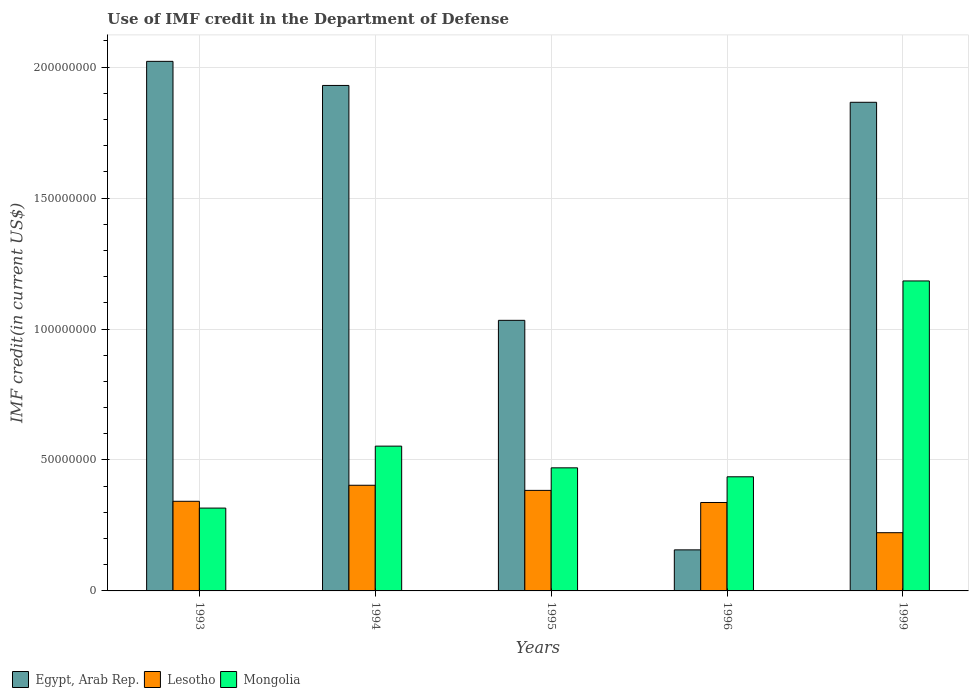How many different coloured bars are there?
Your answer should be very brief. 3. How many groups of bars are there?
Your answer should be very brief. 5. Are the number of bars per tick equal to the number of legend labels?
Your answer should be very brief. Yes. Are the number of bars on each tick of the X-axis equal?
Offer a very short reply. Yes. How many bars are there on the 1st tick from the left?
Ensure brevity in your answer.  3. In how many cases, is the number of bars for a given year not equal to the number of legend labels?
Your answer should be compact. 0. What is the IMF credit in the Department of Defense in Egypt, Arab Rep. in 1994?
Your response must be concise. 1.93e+08. Across all years, what is the maximum IMF credit in the Department of Defense in Mongolia?
Provide a succinct answer. 1.18e+08. Across all years, what is the minimum IMF credit in the Department of Defense in Mongolia?
Your answer should be very brief. 3.16e+07. In which year was the IMF credit in the Department of Defense in Lesotho maximum?
Your answer should be compact. 1994. What is the total IMF credit in the Department of Defense in Mongolia in the graph?
Offer a terse response. 2.96e+08. What is the difference between the IMF credit in the Department of Defense in Egypt, Arab Rep. in 1993 and that in 1994?
Provide a short and direct response. 9.20e+06. What is the difference between the IMF credit in the Department of Defense in Lesotho in 1993 and the IMF credit in the Department of Defense in Egypt, Arab Rep. in 1996?
Make the answer very short. 1.85e+07. What is the average IMF credit in the Department of Defense in Lesotho per year?
Provide a succinct answer. 3.38e+07. In the year 1996, what is the difference between the IMF credit in the Department of Defense in Lesotho and IMF credit in the Department of Defense in Mongolia?
Your answer should be compact. -9.81e+06. In how many years, is the IMF credit in the Department of Defense in Mongolia greater than 80000000 US$?
Keep it short and to the point. 1. What is the ratio of the IMF credit in the Department of Defense in Lesotho in 1995 to that in 1996?
Your answer should be compact. 1.14. Is the difference between the IMF credit in the Department of Defense in Lesotho in 1993 and 1994 greater than the difference between the IMF credit in the Department of Defense in Mongolia in 1993 and 1994?
Offer a terse response. Yes. What is the difference between the highest and the second highest IMF credit in the Department of Defense in Egypt, Arab Rep.?
Ensure brevity in your answer.  9.20e+06. What is the difference between the highest and the lowest IMF credit in the Department of Defense in Egypt, Arab Rep.?
Your answer should be very brief. 1.87e+08. Is the sum of the IMF credit in the Department of Defense in Lesotho in 1995 and 1999 greater than the maximum IMF credit in the Department of Defense in Mongolia across all years?
Your answer should be very brief. No. What does the 1st bar from the left in 1995 represents?
Your answer should be very brief. Egypt, Arab Rep. What does the 1st bar from the right in 1996 represents?
Your answer should be compact. Mongolia. How many bars are there?
Make the answer very short. 15. Does the graph contain grids?
Offer a very short reply. Yes. Where does the legend appear in the graph?
Ensure brevity in your answer.  Bottom left. How many legend labels are there?
Offer a terse response. 3. What is the title of the graph?
Keep it short and to the point. Use of IMF credit in the Department of Defense. Does "Vanuatu" appear as one of the legend labels in the graph?
Ensure brevity in your answer.  No. What is the label or title of the X-axis?
Offer a terse response. Years. What is the label or title of the Y-axis?
Your answer should be very brief. IMF credit(in current US$). What is the IMF credit(in current US$) in Egypt, Arab Rep. in 1993?
Offer a very short reply. 2.02e+08. What is the IMF credit(in current US$) in Lesotho in 1993?
Make the answer very short. 3.42e+07. What is the IMF credit(in current US$) of Mongolia in 1993?
Keep it short and to the point. 3.16e+07. What is the IMF credit(in current US$) in Egypt, Arab Rep. in 1994?
Offer a terse response. 1.93e+08. What is the IMF credit(in current US$) of Lesotho in 1994?
Provide a succinct answer. 4.03e+07. What is the IMF credit(in current US$) in Mongolia in 1994?
Give a very brief answer. 5.53e+07. What is the IMF credit(in current US$) of Egypt, Arab Rep. in 1995?
Offer a terse response. 1.03e+08. What is the IMF credit(in current US$) in Lesotho in 1995?
Provide a short and direct response. 3.84e+07. What is the IMF credit(in current US$) in Mongolia in 1995?
Offer a very short reply. 4.70e+07. What is the IMF credit(in current US$) in Egypt, Arab Rep. in 1996?
Provide a short and direct response. 1.57e+07. What is the IMF credit(in current US$) of Lesotho in 1996?
Your response must be concise. 3.38e+07. What is the IMF credit(in current US$) of Mongolia in 1996?
Give a very brief answer. 4.36e+07. What is the IMF credit(in current US$) in Egypt, Arab Rep. in 1999?
Your answer should be very brief. 1.87e+08. What is the IMF credit(in current US$) in Lesotho in 1999?
Ensure brevity in your answer.  2.22e+07. What is the IMF credit(in current US$) of Mongolia in 1999?
Keep it short and to the point. 1.18e+08. Across all years, what is the maximum IMF credit(in current US$) of Egypt, Arab Rep.?
Your response must be concise. 2.02e+08. Across all years, what is the maximum IMF credit(in current US$) of Lesotho?
Provide a succinct answer. 4.03e+07. Across all years, what is the maximum IMF credit(in current US$) in Mongolia?
Your answer should be compact. 1.18e+08. Across all years, what is the minimum IMF credit(in current US$) of Egypt, Arab Rep.?
Offer a very short reply. 1.57e+07. Across all years, what is the minimum IMF credit(in current US$) in Lesotho?
Your answer should be very brief. 2.22e+07. Across all years, what is the minimum IMF credit(in current US$) of Mongolia?
Offer a terse response. 3.16e+07. What is the total IMF credit(in current US$) of Egypt, Arab Rep. in the graph?
Ensure brevity in your answer.  7.01e+08. What is the total IMF credit(in current US$) in Lesotho in the graph?
Offer a very short reply. 1.69e+08. What is the total IMF credit(in current US$) in Mongolia in the graph?
Your answer should be very brief. 2.96e+08. What is the difference between the IMF credit(in current US$) of Egypt, Arab Rep. in 1993 and that in 1994?
Keep it short and to the point. 9.20e+06. What is the difference between the IMF credit(in current US$) of Lesotho in 1993 and that in 1994?
Provide a short and direct response. -6.12e+06. What is the difference between the IMF credit(in current US$) of Mongolia in 1993 and that in 1994?
Your answer should be very brief. -2.37e+07. What is the difference between the IMF credit(in current US$) of Egypt, Arab Rep. in 1993 and that in 1995?
Ensure brevity in your answer.  9.89e+07. What is the difference between the IMF credit(in current US$) in Lesotho in 1993 and that in 1995?
Offer a very short reply. -4.16e+06. What is the difference between the IMF credit(in current US$) in Mongolia in 1993 and that in 1995?
Keep it short and to the point. -1.54e+07. What is the difference between the IMF credit(in current US$) in Egypt, Arab Rep. in 1993 and that in 1996?
Provide a short and direct response. 1.87e+08. What is the difference between the IMF credit(in current US$) in Lesotho in 1993 and that in 1996?
Provide a succinct answer. 4.57e+05. What is the difference between the IMF credit(in current US$) of Mongolia in 1993 and that in 1996?
Offer a terse response. -1.20e+07. What is the difference between the IMF credit(in current US$) of Egypt, Arab Rep. in 1993 and that in 1999?
Keep it short and to the point. 1.56e+07. What is the difference between the IMF credit(in current US$) in Lesotho in 1993 and that in 1999?
Your answer should be compact. 1.20e+07. What is the difference between the IMF credit(in current US$) of Mongolia in 1993 and that in 1999?
Offer a terse response. -8.67e+07. What is the difference between the IMF credit(in current US$) of Egypt, Arab Rep. in 1994 and that in 1995?
Your answer should be compact. 8.97e+07. What is the difference between the IMF credit(in current US$) in Lesotho in 1994 and that in 1995?
Your response must be concise. 1.96e+06. What is the difference between the IMF credit(in current US$) of Mongolia in 1994 and that in 1995?
Provide a succinct answer. 8.28e+06. What is the difference between the IMF credit(in current US$) in Egypt, Arab Rep. in 1994 and that in 1996?
Provide a succinct answer. 1.77e+08. What is the difference between the IMF credit(in current US$) of Lesotho in 1994 and that in 1996?
Give a very brief answer. 6.58e+06. What is the difference between the IMF credit(in current US$) of Mongolia in 1994 and that in 1996?
Provide a succinct answer. 1.17e+07. What is the difference between the IMF credit(in current US$) in Egypt, Arab Rep. in 1994 and that in 1999?
Offer a very short reply. 6.44e+06. What is the difference between the IMF credit(in current US$) of Lesotho in 1994 and that in 1999?
Offer a terse response. 1.81e+07. What is the difference between the IMF credit(in current US$) in Mongolia in 1994 and that in 1999?
Your answer should be compact. -6.31e+07. What is the difference between the IMF credit(in current US$) in Egypt, Arab Rep. in 1995 and that in 1996?
Make the answer very short. 8.76e+07. What is the difference between the IMF credit(in current US$) in Lesotho in 1995 and that in 1996?
Offer a terse response. 4.62e+06. What is the difference between the IMF credit(in current US$) of Mongolia in 1995 and that in 1996?
Your answer should be very brief. 3.42e+06. What is the difference between the IMF credit(in current US$) in Egypt, Arab Rep. in 1995 and that in 1999?
Provide a short and direct response. -8.32e+07. What is the difference between the IMF credit(in current US$) of Lesotho in 1995 and that in 1999?
Provide a succinct answer. 1.62e+07. What is the difference between the IMF credit(in current US$) of Mongolia in 1995 and that in 1999?
Your answer should be very brief. -7.14e+07. What is the difference between the IMF credit(in current US$) in Egypt, Arab Rep. in 1996 and that in 1999?
Keep it short and to the point. -1.71e+08. What is the difference between the IMF credit(in current US$) of Lesotho in 1996 and that in 1999?
Provide a succinct answer. 1.15e+07. What is the difference between the IMF credit(in current US$) of Mongolia in 1996 and that in 1999?
Make the answer very short. -7.48e+07. What is the difference between the IMF credit(in current US$) of Egypt, Arab Rep. in 1993 and the IMF credit(in current US$) of Lesotho in 1994?
Your answer should be very brief. 1.62e+08. What is the difference between the IMF credit(in current US$) in Egypt, Arab Rep. in 1993 and the IMF credit(in current US$) in Mongolia in 1994?
Your answer should be compact. 1.47e+08. What is the difference between the IMF credit(in current US$) in Lesotho in 1993 and the IMF credit(in current US$) in Mongolia in 1994?
Offer a very short reply. -2.11e+07. What is the difference between the IMF credit(in current US$) of Egypt, Arab Rep. in 1993 and the IMF credit(in current US$) of Lesotho in 1995?
Offer a very short reply. 1.64e+08. What is the difference between the IMF credit(in current US$) in Egypt, Arab Rep. in 1993 and the IMF credit(in current US$) in Mongolia in 1995?
Make the answer very short. 1.55e+08. What is the difference between the IMF credit(in current US$) in Lesotho in 1993 and the IMF credit(in current US$) in Mongolia in 1995?
Offer a terse response. -1.28e+07. What is the difference between the IMF credit(in current US$) in Egypt, Arab Rep. in 1993 and the IMF credit(in current US$) in Lesotho in 1996?
Provide a short and direct response. 1.68e+08. What is the difference between the IMF credit(in current US$) in Egypt, Arab Rep. in 1993 and the IMF credit(in current US$) in Mongolia in 1996?
Provide a succinct answer. 1.59e+08. What is the difference between the IMF credit(in current US$) in Lesotho in 1993 and the IMF credit(in current US$) in Mongolia in 1996?
Your answer should be very brief. -9.36e+06. What is the difference between the IMF credit(in current US$) in Egypt, Arab Rep. in 1993 and the IMF credit(in current US$) in Lesotho in 1999?
Give a very brief answer. 1.80e+08. What is the difference between the IMF credit(in current US$) of Egypt, Arab Rep. in 1993 and the IMF credit(in current US$) of Mongolia in 1999?
Keep it short and to the point. 8.38e+07. What is the difference between the IMF credit(in current US$) of Lesotho in 1993 and the IMF credit(in current US$) of Mongolia in 1999?
Offer a very short reply. -8.41e+07. What is the difference between the IMF credit(in current US$) of Egypt, Arab Rep. in 1994 and the IMF credit(in current US$) of Lesotho in 1995?
Ensure brevity in your answer.  1.55e+08. What is the difference between the IMF credit(in current US$) in Egypt, Arab Rep. in 1994 and the IMF credit(in current US$) in Mongolia in 1995?
Your answer should be compact. 1.46e+08. What is the difference between the IMF credit(in current US$) of Lesotho in 1994 and the IMF credit(in current US$) of Mongolia in 1995?
Your answer should be compact. -6.66e+06. What is the difference between the IMF credit(in current US$) in Egypt, Arab Rep. in 1994 and the IMF credit(in current US$) in Lesotho in 1996?
Your answer should be compact. 1.59e+08. What is the difference between the IMF credit(in current US$) in Egypt, Arab Rep. in 1994 and the IMF credit(in current US$) in Mongolia in 1996?
Your answer should be compact. 1.49e+08. What is the difference between the IMF credit(in current US$) of Lesotho in 1994 and the IMF credit(in current US$) of Mongolia in 1996?
Ensure brevity in your answer.  -3.24e+06. What is the difference between the IMF credit(in current US$) in Egypt, Arab Rep. in 1994 and the IMF credit(in current US$) in Lesotho in 1999?
Provide a short and direct response. 1.71e+08. What is the difference between the IMF credit(in current US$) in Egypt, Arab Rep. in 1994 and the IMF credit(in current US$) in Mongolia in 1999?
Make the answer very short. 7.46e+07. What is the difference between the IMF credit(in current US$) of Lesotho in 1994 and the IMF credit(in current US$) of Mongolia in 1999?
Keep it short and to the point. -7.80e+07. What is the difference between the IMF credit(in current US$) in Egypt, Arab Rep. in 1995 and the IMF credit(in current US$) in Lesotho in 1996?
Provide a succinct answer. 6.95e+07. What is the difference between the IMF credit(in current US$) of Egypt, Arab Rep. in 1995 and the IMF credit(in current US$) of Mongolia in 1996?
Your answer should be compact. 5.97e+07. What is the difference between the IMF credit(in current US$) of Lesotho in 1995 and the IMF credit(in current US$) of Mongolia in 1996?
Your answer should be very brief. -5.20e+06. What is the difference between the IMF credit(in current US$) of Egypt, Arab Rep. in 1995 and the IMF credit(in current US$) of Lesotho in 1999?
Provide a succinct answer. 8.11e+07. What is the difference between the IMF credit(in current US$) of Egypt, Arab Rep. in 1995 and the IMF credit(in current US$) of Mongolia in 1999?
Keep it short and to the point. -1.50e+07. What is the difference between the IMF credit(in current US$) in Lesotho in 1995 and the IMF credit(in current US$) in Mongolia in 1999?
Give a very brief answer. -8.00e+07. What is the difference between the IMF credit(in current US$) of Egypt, Arab Rep. in 1996 and the IMF credit(in current US$) of Lesotho in 1999?
Offer a terse response. -6.56e+06. What is the difference between the IMF credit(in current US$) of Egypt, Arab Rep. in 1996 and the IMF credit(in current US$) of Mongolia in 1999?
Your answer should be very brief. -1.03e+08. What is the difference between the IMF credit(in current US$) of Lesotho in 1996 and the IMF credit(in current US$) of Mongolia in 1999?
Ensure brevity in your answer.  -8.46e+07. What is the average IMF credit(in current US$) of Egypt, Arab Rep. per year?
Make the answer very short. 1.40e+08. What is the average IMF credit(in current US$) in Lesotho per year?
Provide a succinct answer. 3.38e+07. What is the average IMF credit(in current US$) of Mongolia per year?
Offer a terse response. 5.92e+07. In the year 1993, what is the difference between the IMF credit(in current US$) in Egypt, Arab Rep. and IMF credit(in current US$) in Lesotho?
Provide a short and direct response. 1.68e+08. In the year 1993, what is the difference between the IMF credit(in current US$) in Egypt, Arab Rep. and IMF credit(in current US$) in Mongolia?
Keep it short and to the point. 1.71e+08. In the year 1993, what is the difference between the IMF credit(in current US$) in Lesotho and IMF credit(in current US$) in Mongolia?
Offer a terse response. 2.60e+06. In the year 1994, what is the difference between the IMF credit(in current US$) of Egypt, Arab Rep. and IMF credit(in current US$) of Lesotho?
Make the answer very short. 1.53e+08. In the year 1994, what is the difference between the IMF credit(in current US$) of Egypt, Arab Rep. and IMF credit(in current US$) of Mongolia?
Give a very brief answer. 1.38e+08. In the year 1994, what is the difference between the IMF credit(in current US$) of Lesotho and IMF credit(in current US$) of Mongolia?
Provide a short and direct response. -1.49e+07. In the year 1995, what is the difference between the IMF credit(in current US$) in Egypt, Arab Rep. and IMF credit(in current US$) in Lesotho?
Make the answer very short. 6.49e+07. In the year 1995, what is the difference between the IMF credit(in current US$) in Egypt, Arab Rep. and IMF credit(in current US$) in Mongolia?
Keep it short and to the point. 5.63e+07. In the year 1995, what is the difference between the IMF credit(in current US$) of Lesotho and IMF credit(in current US$) of Mongolia?
Provide a short and direct response. -8.61e+06. In the year 1996, what is the difference between the IMF credit(in current US$) of Egypt, Arab Rep. and IMF credit(in current US$) of Lesotho?
Offer a terse response. -1.81e+07. In the year 1996, what is the difference between the IMF credit(in current US$) in Egypt, Arab Rep. and IMF credit(in current US$) in Mongolia?
Provide a short and direct response. -2.79e+07. In the year 1996, what is the difference between the IMF credit(in current US$) in Lesotho and IMF credit(in current US$) in Mongolia?
Your answer should be very brief. -9.81e+06. In the year 1999, what is the difference between the IMF credit(in current US$) of Egypt, Arab Rep. and IMF credit(in current US$) of Lesotho?
Give a very brief answer. 1.64e+08. In the year 1999, what is the difference between the IMF credit(in current US$) in Egypt, Arab Rep. and IMF credit(in current US$) in Mongolia?
Your response must be concise. 6.82e+07. In the year 1999, what is the difference between the IMF credit(in current US$) of Lesotho and IMF credit(in current US$) of Mongolia?
Your answer should be very brief. -9.61e+07. What is the ratio of the IMF credit(in current US$) in Egypt, Arab Rep. in 1993 to that in 1994?
Your response must be concise. 1.05. What is the ratio of the IMF credit(in current US$) of Lesotho in 1993 to that in 1994?
Provide a short and direct response. 0.85. What is the ratio of the IMF credit(in current US$) of Mongolia in 1993 to that in 1994?
Offer a terse response. 0.57. What is the ratio of the IMF credit(in current US$) of Egypt, Arab Rep. in 1993 to that in 1995?
Offer a terse response. 1.96. What is the ratio of the IMF credit(in current US$) of Lesotho in 1993 to that in 1995?
Offer a terse response. 0.89. What is the ratio of the IMF credit(in current US$) of Mongolia in 1993 to that in 1995?
Give a very brief answer. 0.67. What is the ratio of the IMF credit(in current US$) of Egypt, Arab Rep. in 1993 to that in 1996?
Give a very brief answer. 12.9. What is the ratio of the IMF credit(in current US$) of Lesotho in 1993 to that in 1996?
Offer a terse response. 1.01. What is the ratio of the IMF credit(in current US$) in Mongolia in 1993 to that in 1996?
Your answer should be compact. 0.73. What is the ratio of the IMF credit(in current US$) in Egypt, Arab Rep. in 1993 to that in 1999?
Ensure brevity in your answer.  1.08. What is the ratio of the IMF credit(in current US$) in Lesotho in 1993 to that in 1999?
Give a very brief answer. 1.54. What is the ratio of the IMF credit(in current US$) of Mongolia in 1993 to that in 1999?
Your answer should be compact. 0.27. What is the ratio of the IMF credit(in current US$) in Egypt, Arab Rep. in 1994 to that in 1995?
Make the answer very short. 1.87. What is the ratio of the IMF credit(in current US$) in Lesotho in 1994 to that in 1995?
Offer a terse response. 1.05. What is the ratio of the IMF credit(in current US$) in Mongolia in 1994 to that in 1995?
Ensure brevity in your answer.  1.18. What is the ratio of the IMF credit(in current US$) of Egypt, Arab Rep. in 1994 to that in 1996?
Your response must be concise. 12.31. What is the ratio of the IMF credit(in current US$) of Lesotho in 1994 to that in 1996?
Keep it short and to the point. 1.19. What is the ratio of the IMF credit(in current US$) of Mongolia in 1994 to that in 1996?
Provide a succinct answer. 1.27. What is the ratio of the IMF credit(in current US$) in Egypt, Arab Rep. in 1994 to that in 1999?
Offer a terse response. 1.03. What is the ratio of the IMF credit(in current US$) of Lesotho in 1994 to that in 1999?
Give a very brief answer. 1.81. What is the ratio of the IMF credit(in current US$) in Mongolia in 1994 to that in 1999?
Offer a terse response. 0.47. What is the ratio of the IMF credit(in current US$) in Egypt, Arab Rep. in 1995 to that in 1996?
Offer a terse response. 6.59. What is the ratio of the IMF credit(in current US$) in Lesotho in 1995 to that in 1996?
Ensure brevity in your answer.  1.14. What is the ratio of the IMF credit(in current US$) of Mongolia in 1995 to that in 1996?
Give a very brief answer. 1.08. What is the ratio of the IMF credit(in current US$) in Egypt, Arab Rep. in 1995 to that in 1999?
Offer a very short reply. 0.55. What is the ratio of the IMF credit(in current US$) of Lesotho in 1995 to that in 1999?
Make the answer very short. 1.73. What is the ratio of the IMF credit(in current US$) in Mongolia in 1995 to that in 1999?
Make the answer very short. 0.4. What is the ratio of the IMF credit(in current US$) in Egypt, Arab Rep. in 1996 to that in 1999?
Make the answer very short. 0.08. What is the ratio of the IMF credit(in current US$) in Lesotho in 1996 to that in 1999?
Your answer should be compact. 1.52. What is the ratio of the IMF credit(in current US$) in Mongolia in 1996 to that in 1999?
Offer a very short reply. 0.37. What is the difference between the highest and the second highest IMF credit(in current US$) of Egypt, Arab Rep.?
Your response must be concise. 9.20e+06. What is the difference between the highest and the second highest IMF credit(in current US$) in Lesotho?
Provide a succinct answer. 1.96e+06. What is the difference between the highest and the second highest IMF credit(in current US$) in Mongolia?
Your answer should be very brief. 6.31e+07. What is the difference between the highest and the lowest IMF credit(in current US$) of Egypt, Arab Rep.?
Your answer should be compact. 1.87e+08. What is the difference between the highest and the lowest IMF credit(in current US$) of Lesotho?
Your answer should be very brief. 1.81e+07. What is the difference between the highest and the lowest IMF credit(in current US$) of Mongolia?
Ensure brevity in your answer.  8.67e+07. 